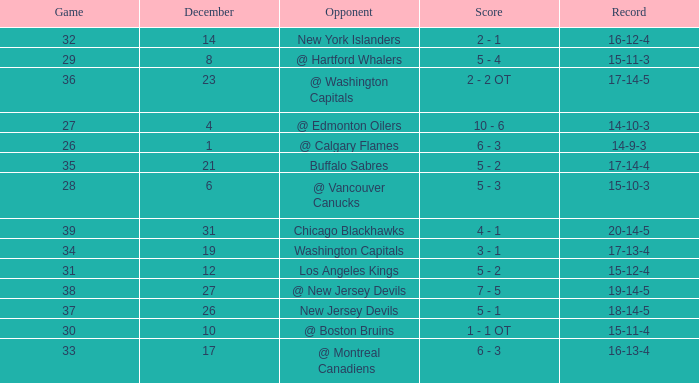Game smaller than 34, and a December smaller than 14, and a Score of 10 - 6 has what opponent? @ Edmonton Oilers. 